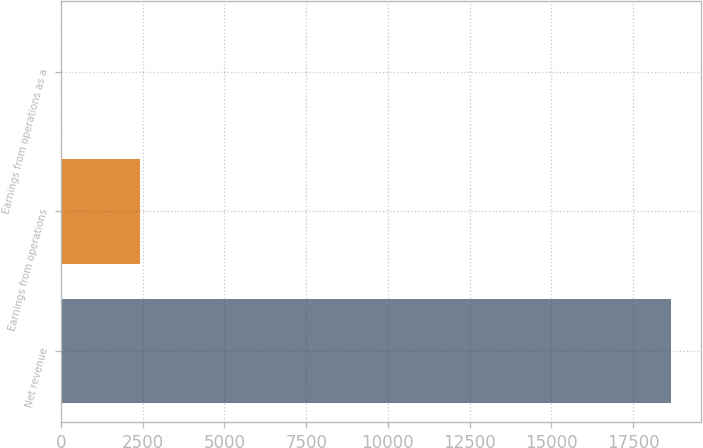Convert chart. <chart><loc_0><loc_0><loc_500><loc_500><bar_chart><fcel>Net revenue<fcel>Earnings from operations<fcel>Earnings from operations as a<nl><fcel>18651<fcel>2402<fcel>12.9<nl></chart> 